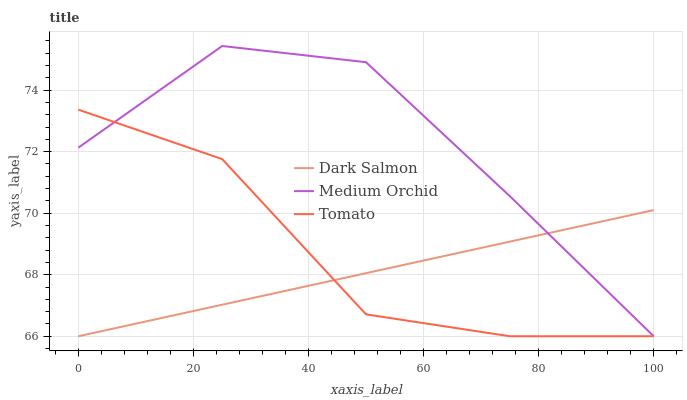Does Dark Salmon have the minimum area under the curve?
Answer yes or no. Yes. Does Medium Orchid have the maximum area under the curve?
Answer yes or no. Yes. Does Medium Orchid have the minimum area under the curve?
Answer yes or no. No. Does Dark Salmon have the maximum area under the curve?
Answer yes or no. No. Is Dark Salmon the smoothest?
Answer yes or no. Yes. Is Tomato the roughest?
Answer yes or no. Yes. Is Medium Orchid the smoothest?
Answer yes or no. No. Is Medium Orchid the roughest?
Answer yes or no. No. Does Tomato have the lowest value?
Answer yes or no. Yes. Does Medium Orchid have the highest value?
Answer yes or no. Yes. Does Dark Salmon have the highest value?
Answer yes or no. No. Does Medium Orchid intersect Dark Salmon?
Answer yes or no. Yes. Is Medium Orchid less than Dark Salmon?
Answer yes or no. No. Is Medium Orchid greater than Dark Salmon?
Answer yes or no. No. 